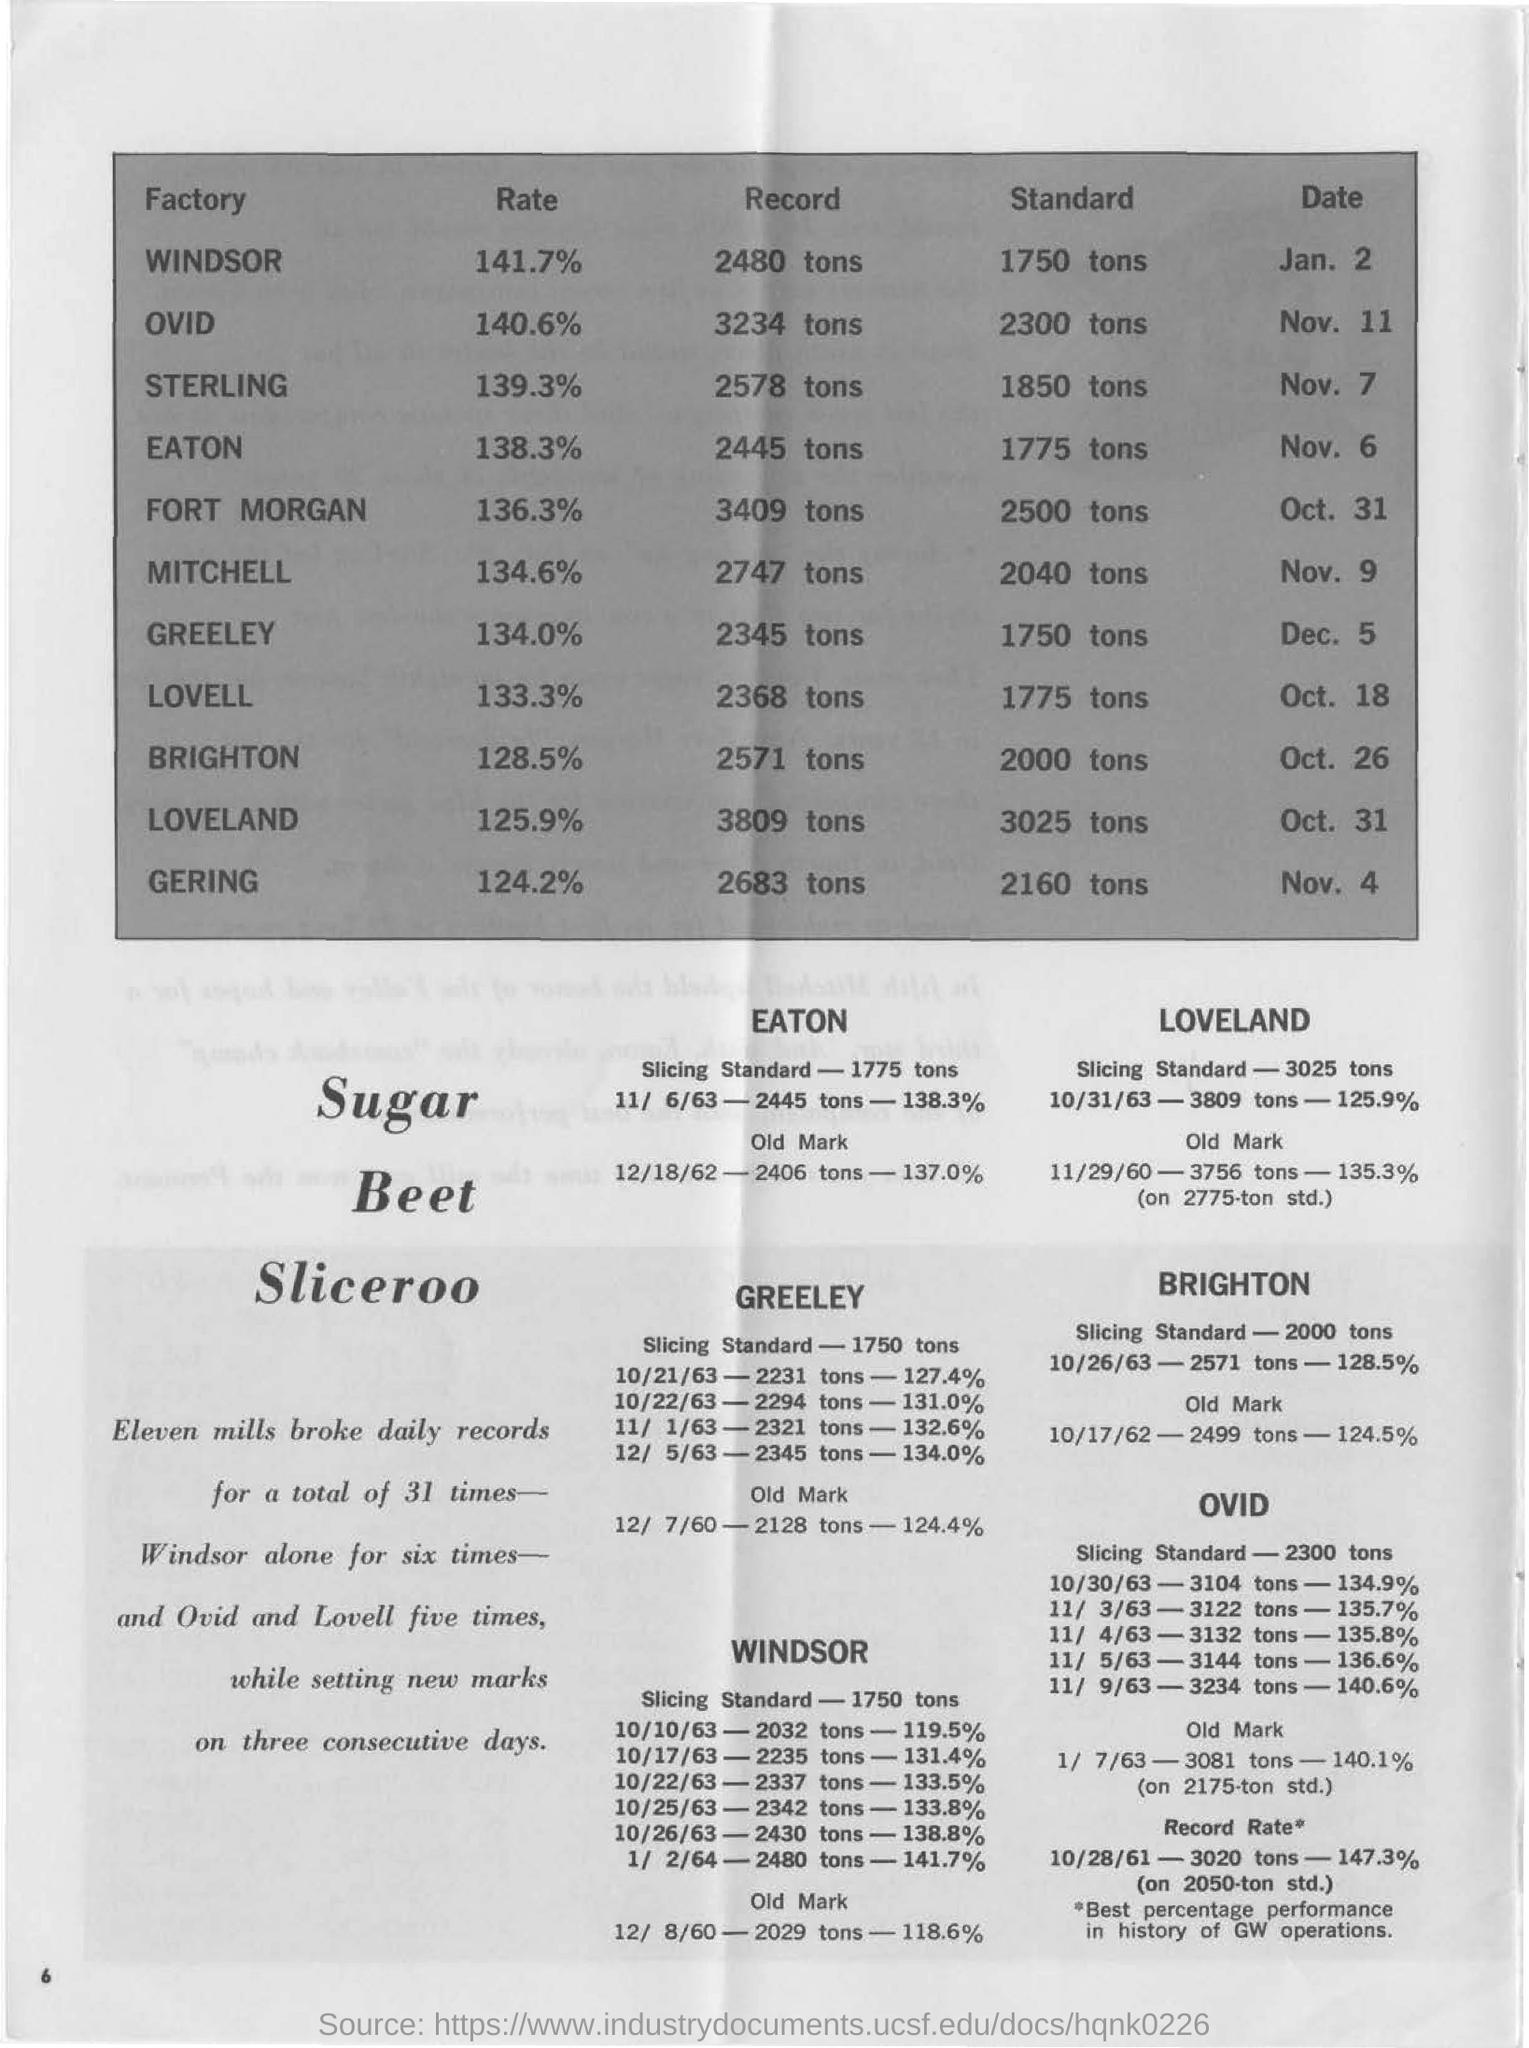What is the date on the windsor "factory"?
Provide a short and direct response. Jan. 2. What is the date on the ovid "factory"?
Give a very brief answer. Nov.  11. What is the date on the lovell "factory"?
Offer a terse response. Oct. 18. What is the standard on the windsor "factory"?
Your answer should be very brief. 1750 TONS. What is the standard on the gering "factory"?
Your answer should be compact. 2160 tons. What is the record on the loveland "factory"?
Give a very brief answer. 3809  tons. 